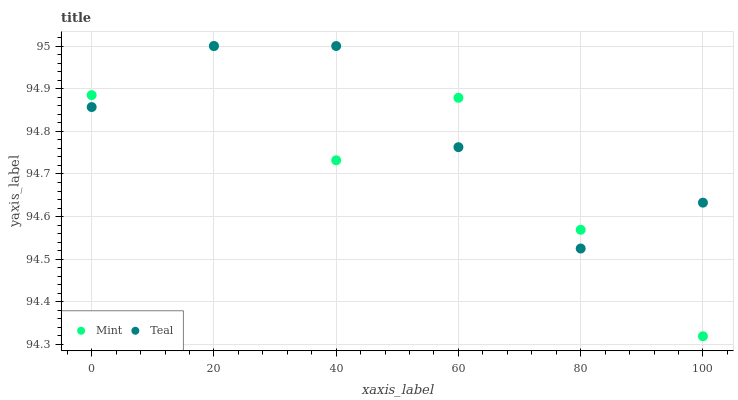Does Mint have the minimum area under the curve?
Answer yes or no. Yes. Does Teal have the maximum area under the curve?
Answer yes or no. Yes. Does Teal have the minimum area under the curve?
Answer yes or no. No. Is Teal the smoothest?
Answer yes or no. Yes. Is Mint the roughest?
Answer yes or no. Yes. Is Teal the roughest?
Answer yes or no. No. Does Mint have the lowest value?
Answer yes or no. Yes. Does Teal have the lowest value?
Answer yes or no. No. Does Teal have the highest value?
Answer yes or no. Yes. Does Teal intersect Mint?
Answer yes or no. Yes. Is Teal less than Mint?
Answer yes or no. No. Is Teal greater than Mint?
Answer yes or no. No. 